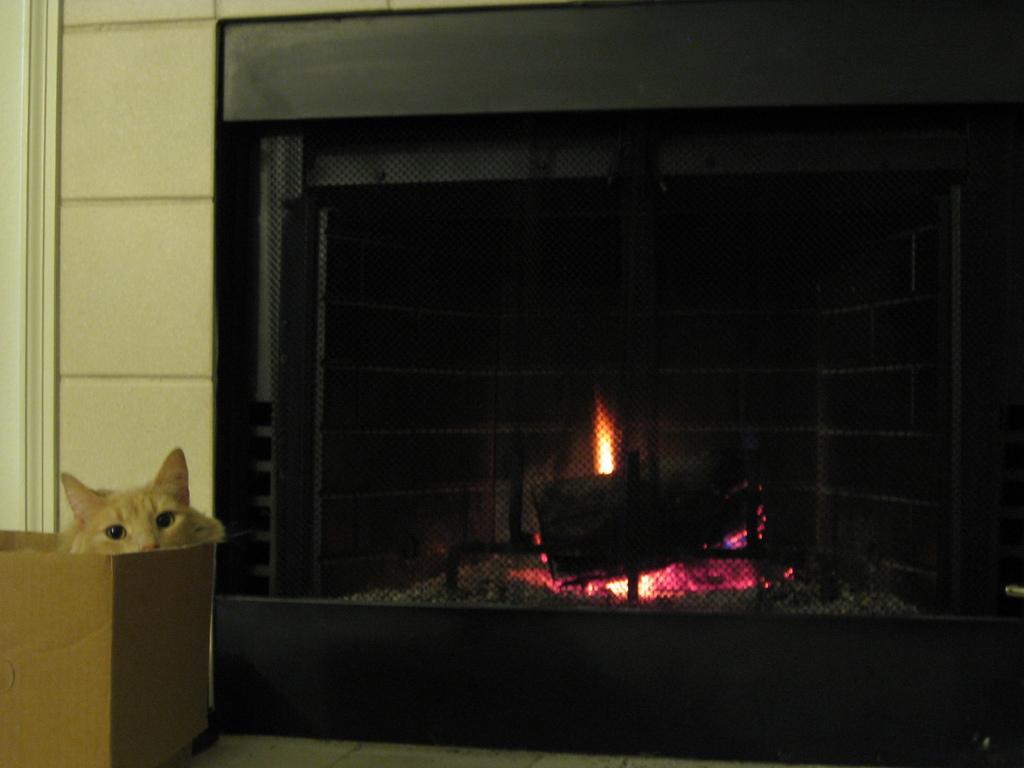Could you give a brief overview of what you see in this image? This image consists of a fireplace in black color. On the left, there is a wall and a cat sitting in the cardboard. 